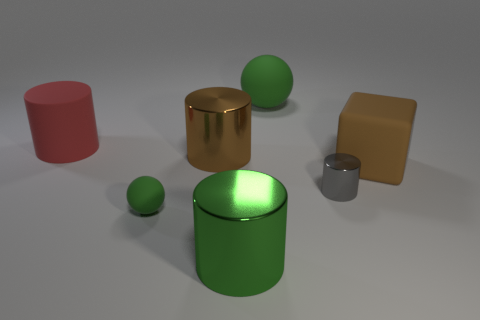Add 2 yellow matte things. How many objects exist? 9 Subtract all cylinders. How many objects are left? 3 Add 6 large green metal cylinders. How many large green metal cylinders are left? 7 Add 1 big brown objects. How many big brown objects exist? 3 Subtract 0 blue cubes. How many objects are left? 7 Subtract all small brown matte balls. Subtract all brown metallic things. How many objects are left? 6 